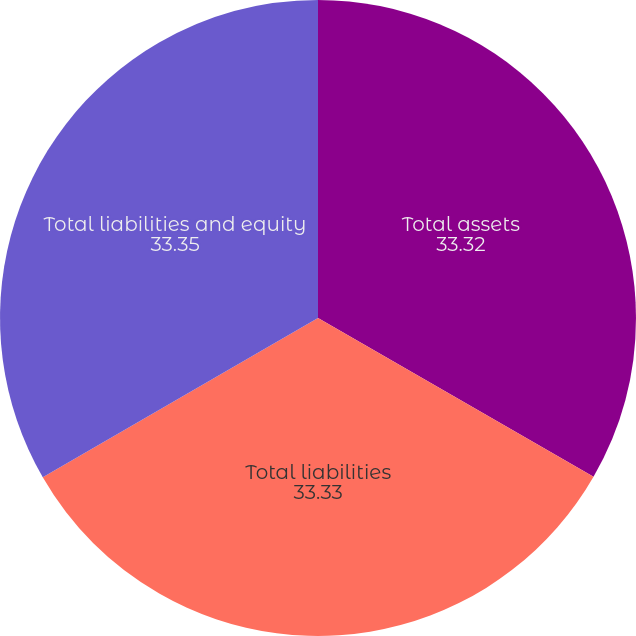Convert chart. <chart><loc_0><loc_0><loc_500><loc_500><pie_chart><fcel>Total assets<fcel>Total liabilities<fcel>Total liabilities and equity<nl><fcel>33.32%<fcel>33.33%<fcel>33.35%<nl></chart> 